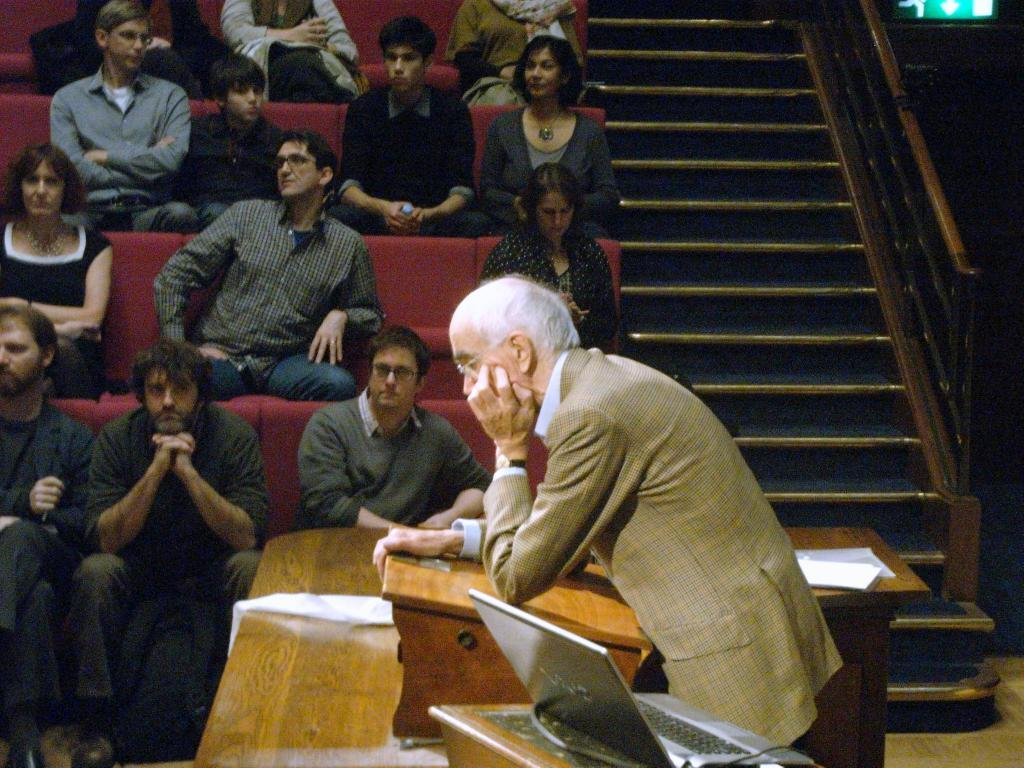What are the people in the image doing? The people in the image are sitting on chairs. What can be seen on the desk in the image? There is a laptop and paper on the desk. Is there any other furniture present in the image? Yes, there is a desk in the image. What is the person standing near the desk doing? It is not clear from the image what the person standing near the desk is doing. What type of prose is being written on the paper on the desk? There is no indication in the image that any prose is being written on the paper. Can you see an apple on the desk in the image? There is no apple present on the desk in the image. 